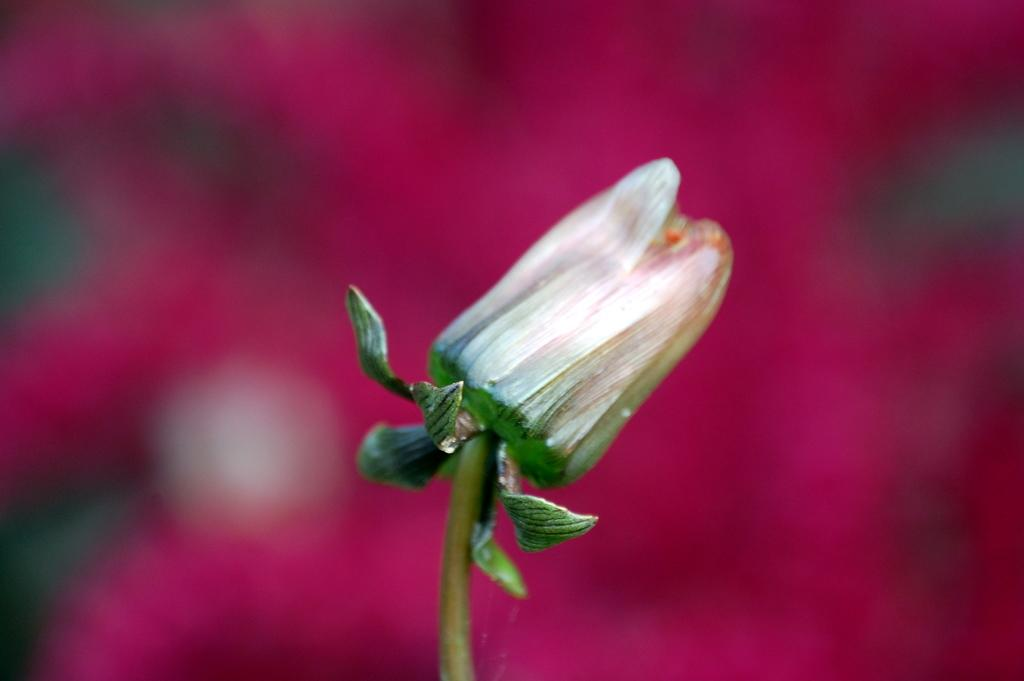What is attached to the stem in the image? A flower is present on the stem in the image. What color is the flower? The flower is white in color. What can be seen in the background of the image? The background of the image is pink. What type of interest is being discussed in the image? There is no discussion of interest in the image; it features a white flower on a stem with a pink background. 